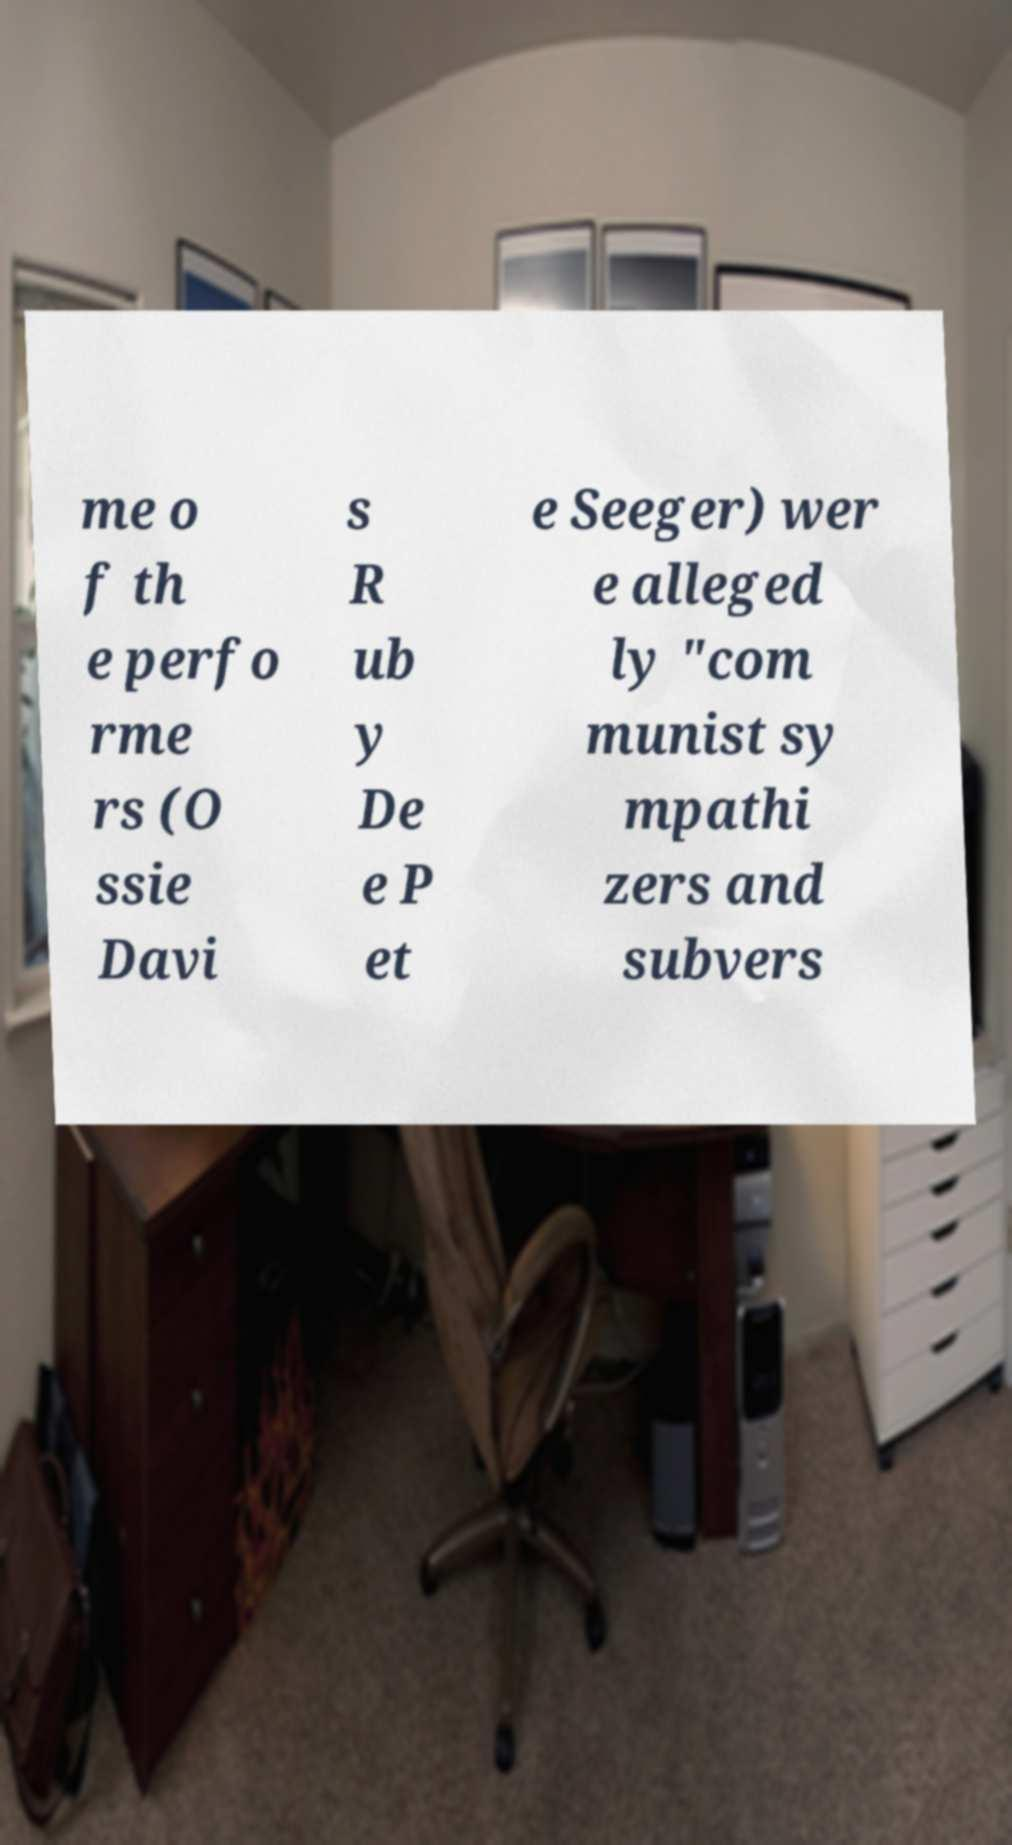Can you tell more about the significance of communism in the context of the names mentioned? The names mentioned, Osise Davis, Ruby Dee, and Pete Seeger, were prominent figures in the arts and were known to have leftist sympathies during a time in America when being associated with communism could lead to significant personal and professional repercussions. Their activism and supposed communist sympathies were subjects of scrutiny under the anti-communist sentiment prevalent during the Cold War era. 